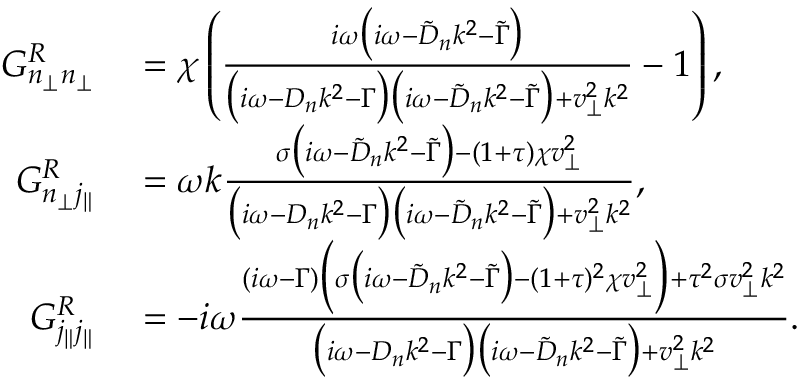<formula> <loc_0><loc_0><loc_500><loc_500>\begin{array} { r l } { G _ { n _ { \perp } n _ { \perp } } ^ { R } } & = \chi \left ( \frac { i \omega \left ( i \omega - \tilde { D } _ { n } k ^ { 2 } - \tilde { \Gamma } \right ) } { \left ( i \omega - D _ { n } k ^ { 2 } - \Gamma \right ) \left ( i \omega - \tilde { D } _ { n } k ^ { 2 } - \tilde { \Gamma } \right ) + v _ { \perp } ^ { 2 } k ^ { 2 } } - 1 \right ) , } \\ { G _ { n _ { \perp } j _ { \| } } ^ { R } } & = \omega k \frac { \sigma \left ( i \omega - \tilde { D } _ { n } k ^ { 2 } - \tilde { \Gamma } \right ) - ( 1 + \tau ) \chi v _ { \perp } ^ { 2 } } { \left ( i \omega - D _ { n } k ^ { 2 } - \Gamma \right ) \left ( i \omega - \tilde { D } _ { n } k ^ { 2 } - \tilde { \Gamma } \right ) + v _ { \perp } ^ { 2 } k ^ { 2 } } , } \\ { G _ { j _ { \| } j _ { \| } } ^ { R } } & = - i \omega \frac { ( i \omega - \Gamma ) \left ( \sigma \left ( i \omega - \tilde { D } _ { n } k ^ { 2 } - \tilde { \Gamma } \right ) - ( 1 + \tau ) ^ { 2 } \chi v _ { \perp } ^ { 2 } \right ) + \tau ^ { 2 } \sigma v _ { \perp } ^ { 2 } k ^ { 2 } } { \left ( i \omega - D _ { n } k ^ { 2 } - \Gamma \right ) \left ( i \omega - \tilde { D } _ { n } k ^ { 2 } - \tilde { \Gamma } \right ) + v _ { \perp } ^ { 2 } k ^ { 2 } } . } \end{array}</formula> 